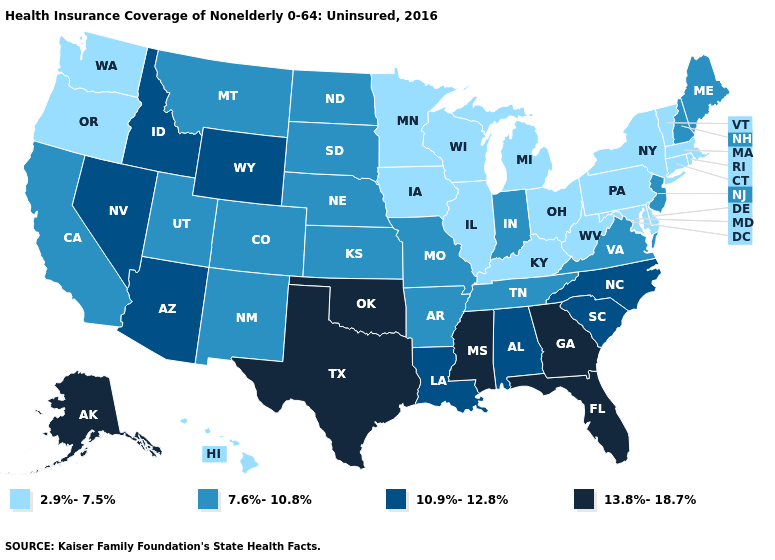Name the states that have a value in the range 7.6%-10.8%?
Give a very brief answer. Arkansas, California, Colorado, Indiana, Kansas, Maine, Missouri, Montana, Nebraska, New Hampshire, New Jersey, New Mexico, North Dakota, South Dakota, Tennessee, Utah, Virginia. Name the states that have a value in the range 2.9%-7.5%?
Write a very short answer. Connecticut, Delaware, Hawaii, Illinois, Iowa, Kentucky, Maryland, Massachusetts, Michigan, Minnesota, New York, Ohio, Oregon, Pennsylvania, Rhode Island, Vermont, Washington, West Virginia, Wisconsin. What is the value of Michigan?
Keep it brief. 2.9%-7.5%. Does New Jersey have the highest value in the Northeast?
Be succinct. Yes. Among the states that border Iowa , does Minnesota have the lowest value?
Answer briefly. Yes. What is the lowest value in the USA?
Write a very short answer. 2.9%-7.5%. Name the states that have a value in the range 2.9%-7.5%?
Short answer required. Connecticut, Delaware, Hawaii, Illinois, Iowa, Kentucky, Maryland, Massachusetts, Michigan, Minnesota, New York, Ohio, Oregon, Pennsylvania, Rhode Island, Vermont, Washington, West Virginia, Wisconsin. Does Kentucky have the lowest value in the South?
Concise answer only. Yes. Does New York have the highest value in the Northeast?
Give a very brief answer. No. What is the value of Georgia?
Give a very brief answer. 13.8%-18.7%. What is the value of Utah?
Give a very brief answer. 7.6%-10.8%. Which states have the lowest value in the Northeast?
Short answer required. Connecticut, Massachusetts, New York, Pennsylvania, Rhode Island, Vermont. Name the states that have a value in the range 2.9%-7.5%?
Write a very short answer. Connecticut, Delaware, Hawaii, Illinois, Iowa, Kentucky, Maryland, Massachusetts, Michigan, Minnesota, New York, Ohio, Oregon, Pennsylvania, Rhode Island, Vermont, Washington, West Virginia, Wisconsin. Does Utah have the lowest value in the West?
Give a very brief answer. No. Name the states that have a value in the range 13.8%-18.7%?
Quick response, please. Alaska, Florida, Georgia, Mississippi, Oklahoma, Texas. 